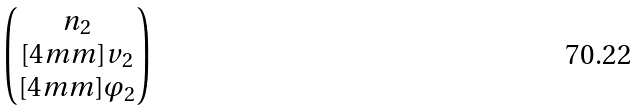Convert formula to latex. <formula><loc_0><loc_0><loc_500><loc_500>\begin{pmatrix} n _ { 2 } \\ [ 4 m m ] v _ { 2 } \\ [ 4 m m ] \varphi _ { 2 } \end{pmatrix}</formula> 